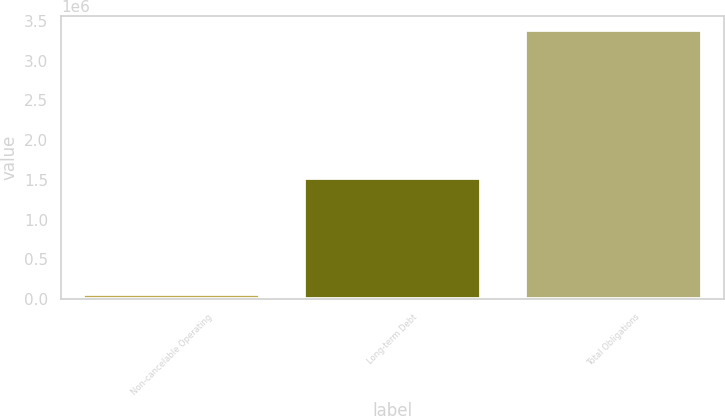<chart> <loc_0><loc_0><loc_500><loc_500><bar_chart><fcel>Non-cancelable Operating<fcel>Long-term Debt<fcel>Total Obligations<nl><fcel>61104<fcel>1.52434e+06<fcel>3.38824e+06<nl></chart> 